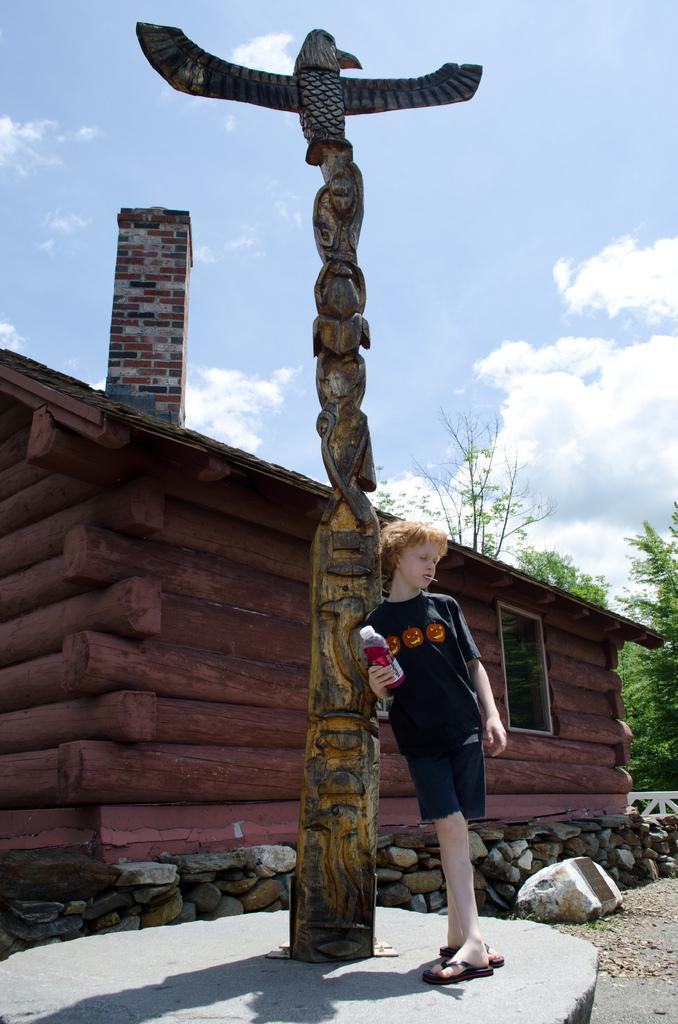Can you describe this image briefly? In this picture I can see a sculpture in front and I can see a boy near to it and he is holding a bottle. In the background I can see a house, number of stones, few trees and I can see the clear sky. 